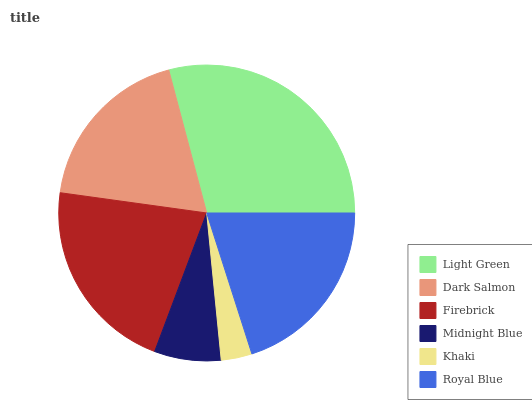Is Khaki the minimum?
Answer yes or no. Yes. Is Light Green the maximum?
Answer yes or no. Yes. Is Dark Salmon the minimum?
Answer yes or no. No. Is Dark Salmon the maximum?
Answer yes or no. No. Is Light Green greater than Dark Salmon?
Answer yes or no. Yes. Is Dark Salmon less than Light Green?
Answer yes or no. Yes. Is Dark Salmon greater than Light Green?
Answer yes or no. No. Is Light Green less than Dark Salmon?
Answer yes or no. No. Is Royal Blue the high median?
Answer yes or no. Yes. Is Dark Salmon the low median?
Answer yes or no. Yes. Is Light Green the high median?
Answer yes or no. No. Is Firebrick the low median?
Answer yes or no. No. 